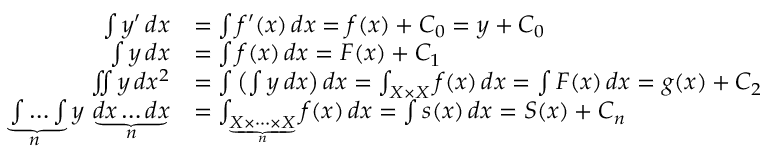Convert formula to latex. <formula><loc_0><loc_0><loc_500><loc_500>{ \begin{array} { r l } { \int y ^ { \prime } \, d x } & { = \int f ^ { \prime } ( x ) \, d x = f ( x ) + C _ { 0 } = y + C _ { 0 } } \\ { \int y \, d x } & { = \int f ( x ) \, d x = F ( x ) + C _ { 1 } } \\ { \iint y \, d x ^ { 2 } } & { = \int \left ( \int y \, d x \right ) d x = \int _ { X \times X } f ( x ) \, d x = \int F ( x ) \, d x = g ( x ) + C _ { 2 } } \\ { \underbrace { \int \dots \int } _ { \, n } y \, \underbrace { d x \dots d x } _ { n } } & { = \int _ { \underbrace { X \times \cdots \times X } _ { n } } f ( x ) \, d x = \int s ( x ) \, d x = S ( x ) + C _ { n } } \end{array} }</formula> 